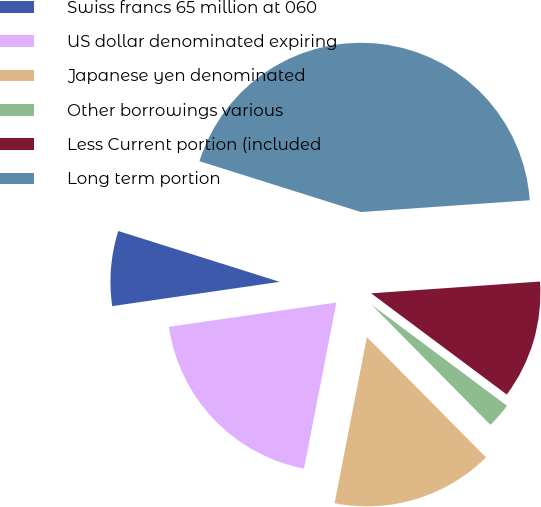Convert chart. <chart><loc_0><loc_0><loc_500><loc_500><pie_chart><fcel>Swiss francs 65 million at 060<fcel>US dollar denominated expiring<fcel>Japanese yen denominated<fcel>Other borrowings various<fcel>Less Current portion (included<fcel>Long term portion<nl><fcel>7.15%<fcel>19.65%<fcel>15.48%<fcel>2.38%<fcel>11.31%<fcel>44.04%<nl></chart> 